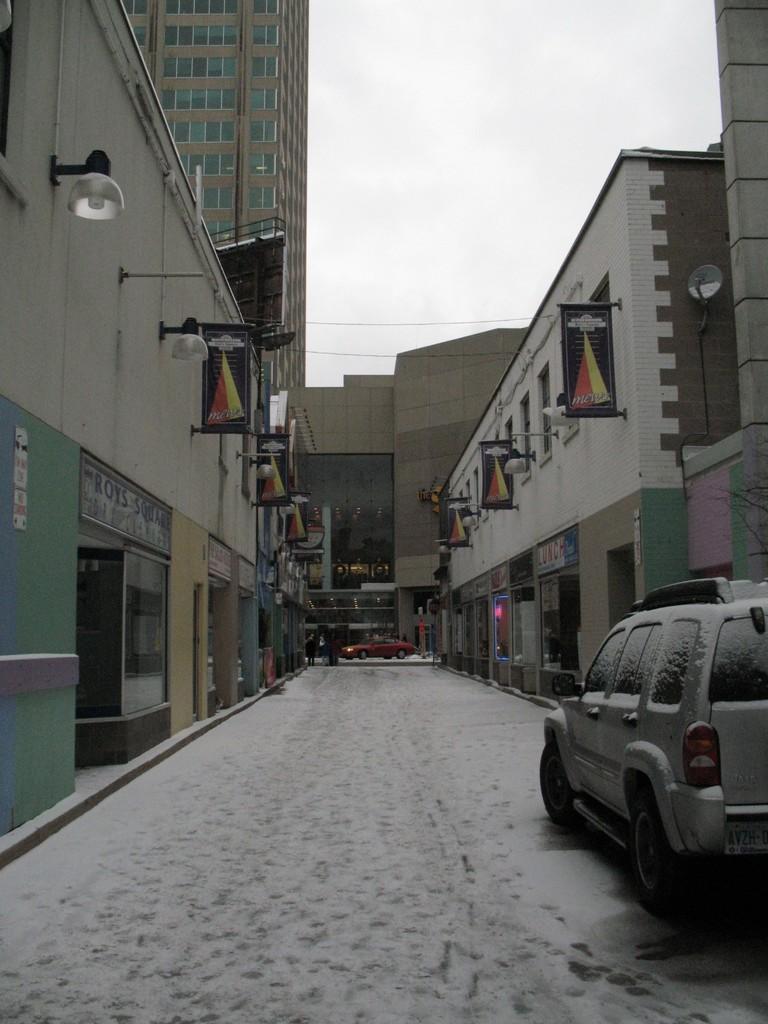How would you summarize this image in a sentence or two? In this image in the middle there is a path. On the path there are vehicles. On both sides of the path there are buildings. The sky is clear. 